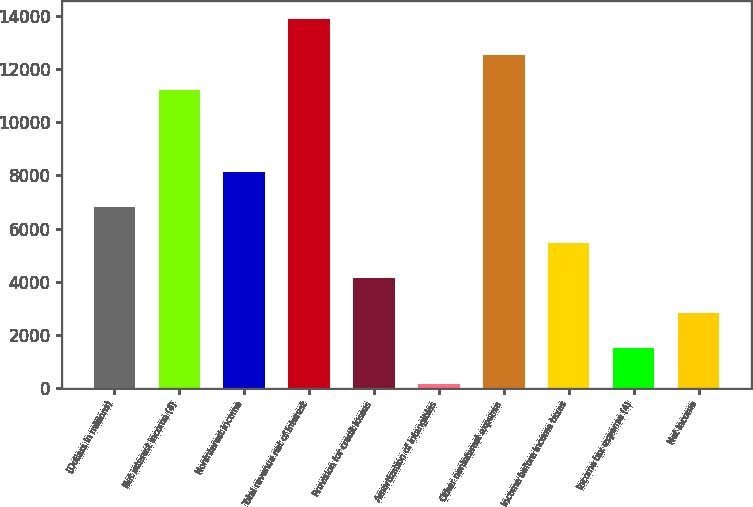Convert chart to OTSL. <chart><loc_0><loc_0><loc_500><loc_500><bar_chart><fcel>(Dollars in millions)<fcel>Net interest income (4)<fcel>Noninterest income<fcel>Total revenue net of interest<fcel>Provision for credit losses<fcel>Amortization of intangibles<fcel>Other noninterest expense<fcel>Income before income taxes<fcel>Income tax expense (4)<fcel>Net income<nl><fcel>6797.5<fcel>11217<fcel>8121.4<fcel>13864.8<fcel>4149.7<fcel>178<fcel>12540.9<fcel>5473.6<fcel>1501.9<fcel>2825.8<nl></chart> 